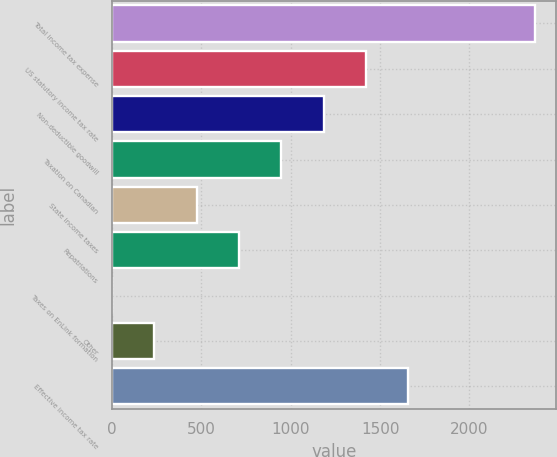<chart> <loc_0><loc_0><loc_500><loc_500><bar_chart><fcel>Total income tax expense<fcel>US statutory income tax rate<fcel>Non-deductible goodwill<fcel>Taxation on Canadian<fcel>State income taxes<fcel>Repatriations<fcel>Taxes on EnLink formation<fcel>Other<fcel>Effective income tax rate<nl><fcel>2368<fcel>1421.2<fcel>1184.5<fcel>947.8<fcel>474.4<fcel>711.1<fcel>1<fcel>237.7<fcel>1657.9<nl></chart> 